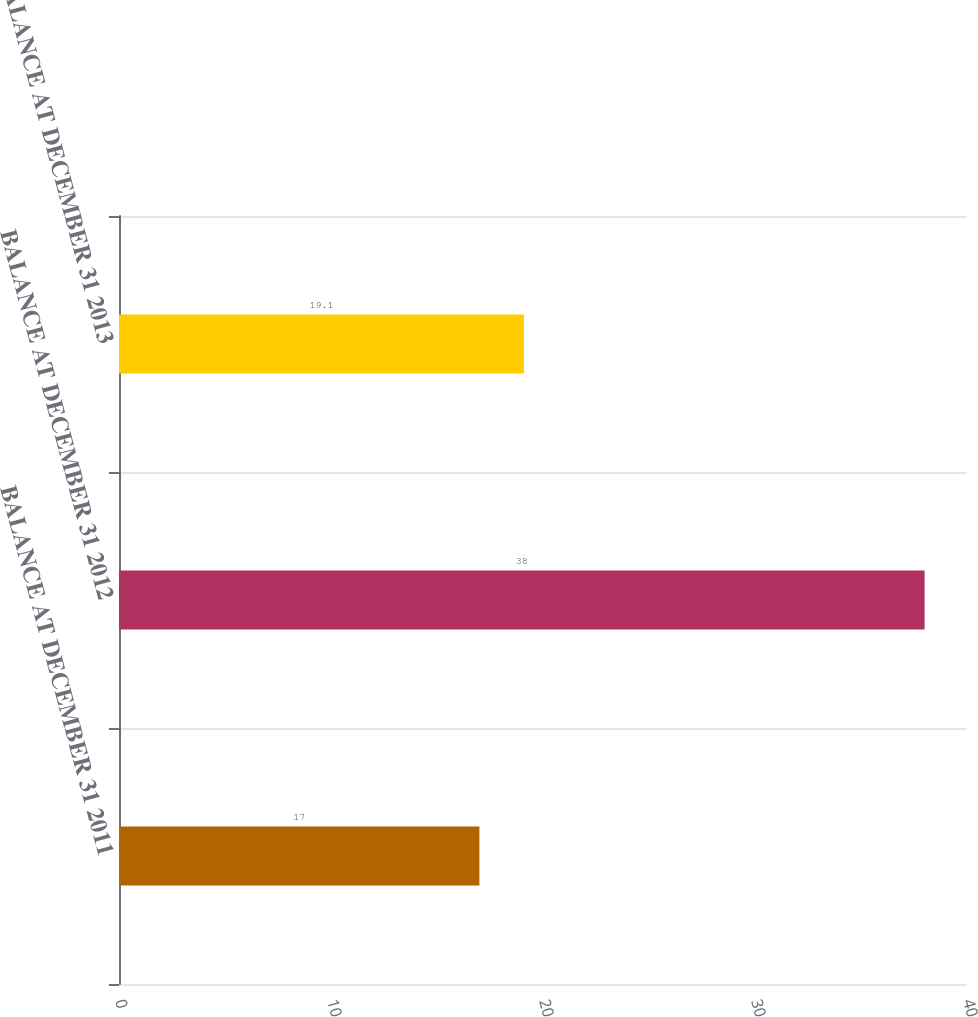<chart> <loc_0><loc_0><loc_500><loc_500><bar_chart><fcel>BALANCE AT DECEMBER 31 2011<fcel>BALANCE AT DECEMBER 31 2012<fcel>BALANCE AT DECEMBER 31 2013<nl><fcel>17<fcel>38<fcel>19.1<nl></chart> 